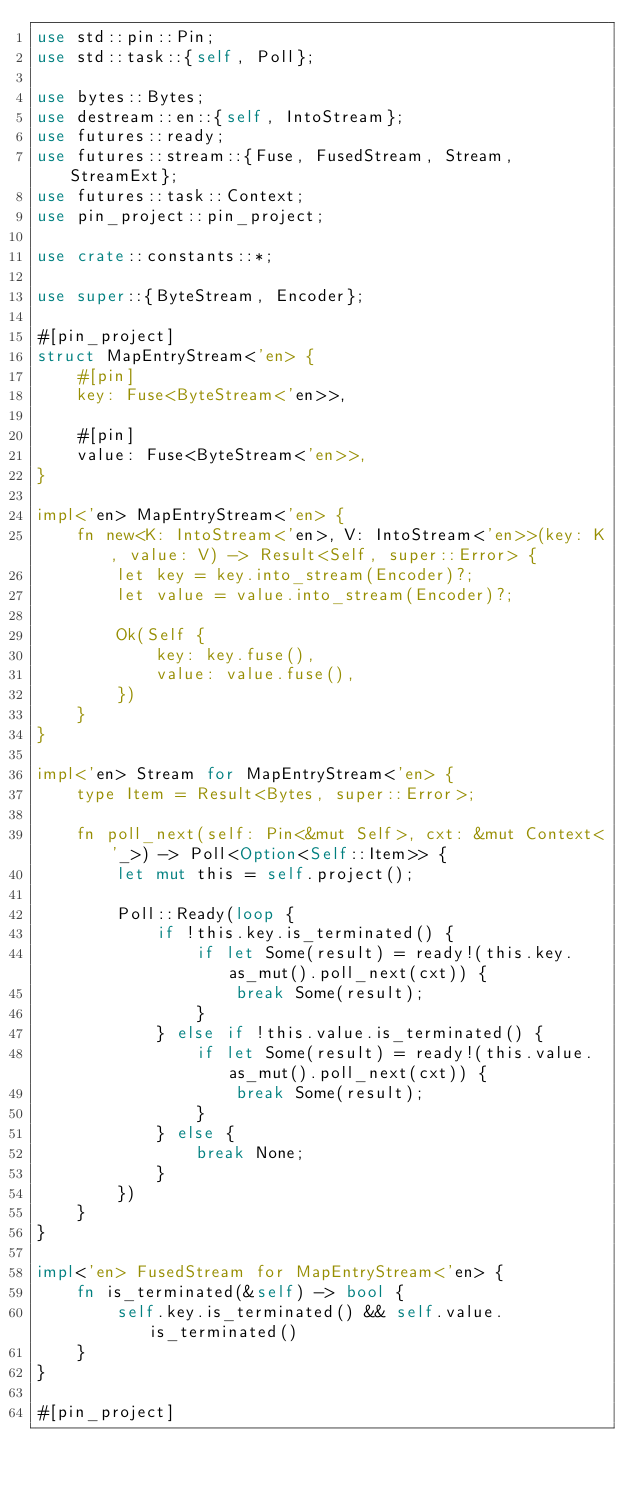<code> <loc_0><loc_0><loc_500><loc_500><_Rust_>use std::pin::Pin;
use std::task::{self, Poll};

use bytes::Bytes;
use destream::en::{self, IntoStream};
use futures::ready;
use futures::stream::{Fuse, FusedStream, Stream, StreamExt};
use futures::task::Context;
use pin_project::pin_project;

use crate::constants::*;

use super::{ByteStream, Encoder};

#[pin_project]
struct MapEntryStream<'en> {
    #[pin]
    key: Fuse<ByteStream<'en>>,

    #[pin]
    value: Fuse<ByteStream<'en>>,
}

impl<'en> MapEntryStream<'en> {
    fn new<K: IntoStream<'en>, V: IntoStream<'en>>(key: K, value: V) -> Result<Self, super::Error> {
        let key = key.into_stream(Encoder)?;
        let value = value.into_stream(Encoder)?;

        Ok(Self {
            key: key.fuse(),
            value: value.fuse(),
        })
    }
}

impl<'en> Stream for MapEntryStream<'en> {
    type Item = Result<Bytes, super::Error>;

    fn poll_next(self: Pin<&mut Self>, cxt: &mut Context<'_>) -> Poll<Option<Self::Item>> {
        let mut this = self.project();

        Poll::Ready(loop {
            if !this.key.is_terminated() {
                if let Some(result) = ready!(this.key.as_mut().poll_next(cxt)) {
                    break Some(result);
                }
            } else if !this.value.is_terminated() {
                if let Some(result) = ready!(this.value.as_mut().poll_next(cxt)) {
                    break Some(result);
                }
            } else {
                break None;
            }
        })
    }
}

impl<'en> FusedStream for MapEntryStream<'en> {
    fn is_terminated(&self) -> bool {
        self.key.is_terminated() && self.value.is_terminated()
    }
}

#[pin_project]</code> 